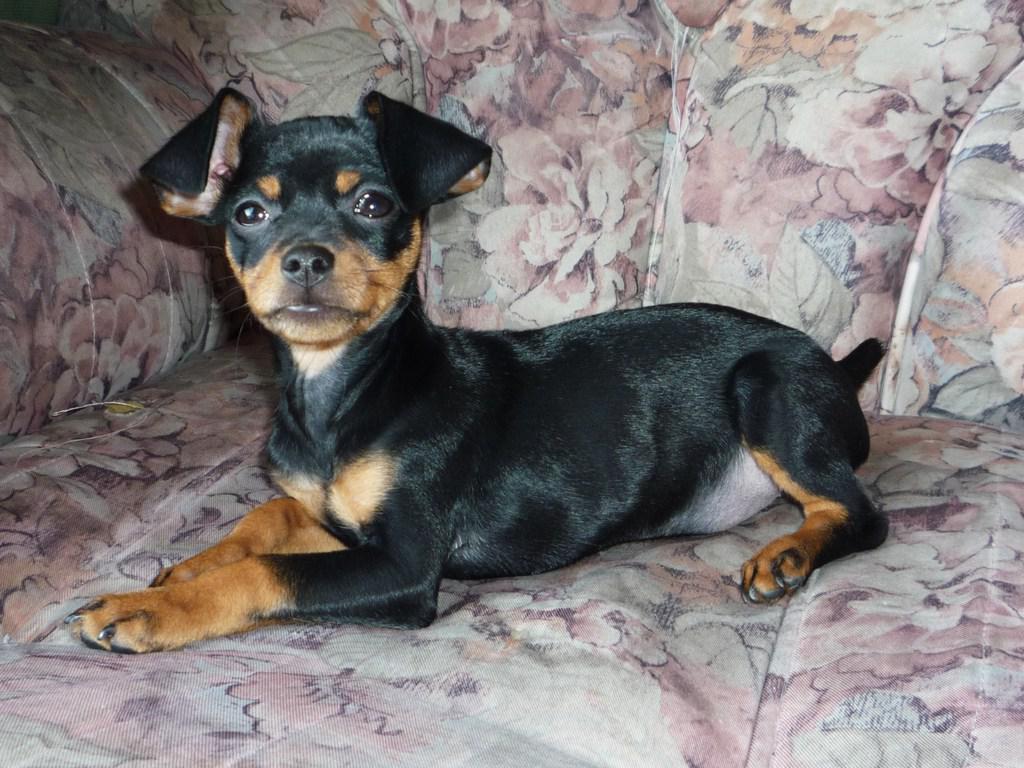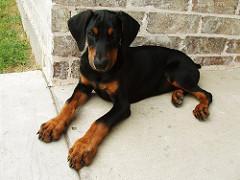The first image is the image on the left, the second image is the image on the right. Examine the images to the left and right. Is the description "The right image features at least two puppies sitting upright with faces forward on a plush white blanket." accurate? Answer yes or no. No. The first image is the image on the left, the second image is the image on the right. Analyze the images presented: Is the assertion "At least one of the dogs is standing on all fours." valid? Answer yes or no. No. 